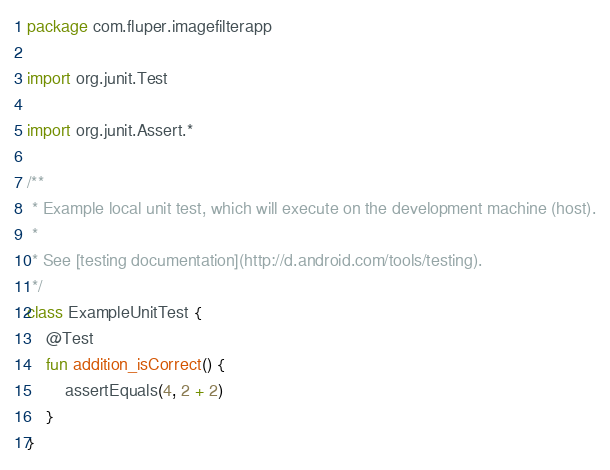<code> <loc_0><loc_0><loc_500><loc_500><_Kotlin_>package com.fluper.imagefilterapp

import org.junit.Test

import org.junit.Assert.*

/**
 * Example local unit test, which will execute on the development machine (host).
 *
 * See [testing documentation](http://d.android.com/tools/testing).
 */
class ExampleUnitTest {
    @Test
    fun addition_isCorrect() {
        assertEquals(4, 2 + 2)
    }
}</code> 